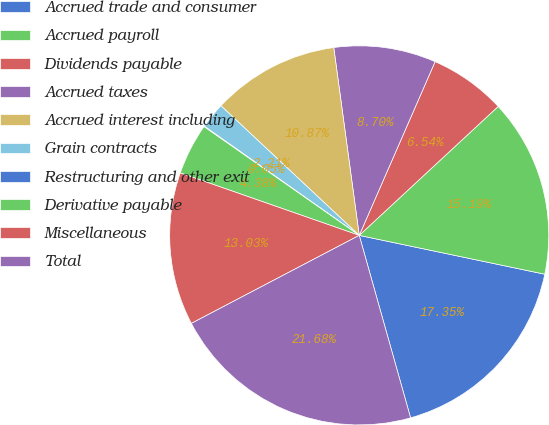Convert chart. <chart><loc_0><loc_0><loc_500><loc_500><pie_chart><fcel>Accrued trade and consumer<fcel>Accrued payroll<fcel>Dividends payable<fcel>Accrued taxes<fcel>Accrued interest including<fcel>Grain contracts<fcel>Restructuring and other exit<fcel>Derivative payable<fcel>Miscellaneous<fcel>Total<nl><fcel>17.35%<fcel>15.19%<fcel>6.54%<fcel>8.7%<fcel>10.87%<fcel>2.21%<fcel>0.05%<fcel>4.38%<fcel>13.03%<fcel>21.68%<nl></chart> 